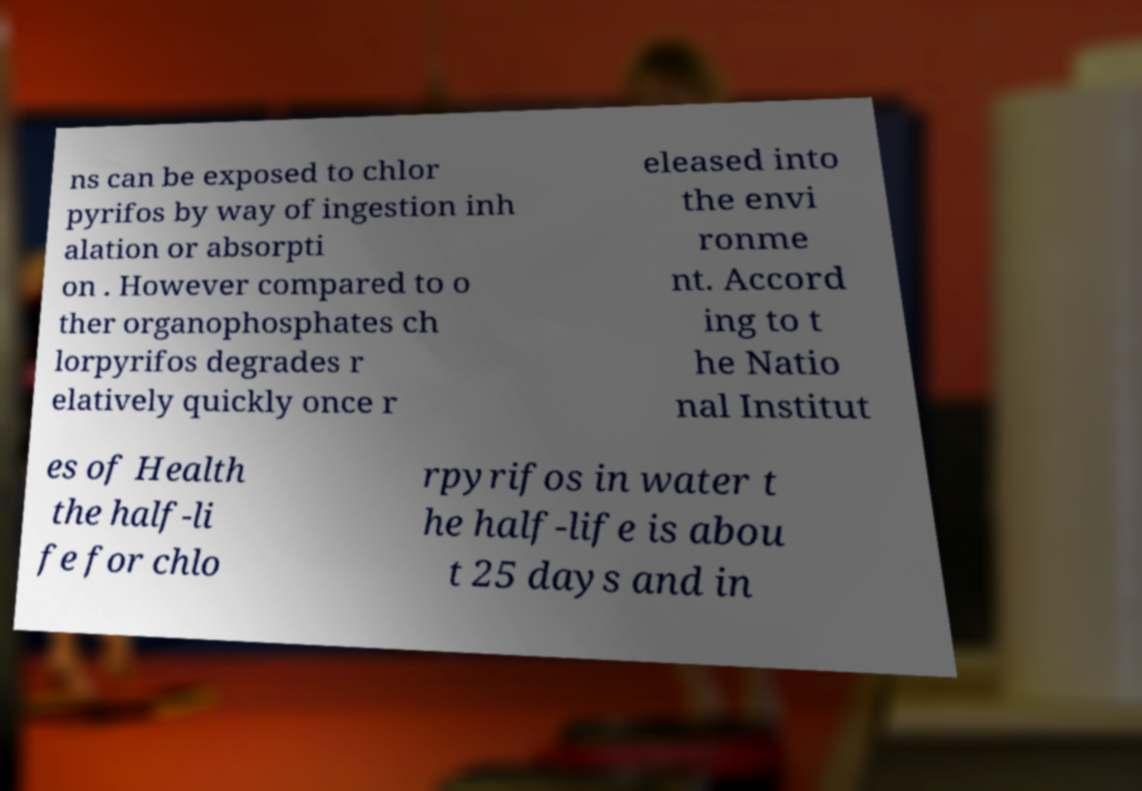What messages or text are displayed in this image? I need them in a readable, typed format. ns can be exposed to chlor pyrifos by way of ingestion inh alation or absorpti on . However compared to o ther organophosphates ch lorpyrifos degrades r elatively quickly once r eleased into the envi ronme nt. Accord ing to t he Natio nal Institut es of Health the half-li fe for chlo rpyrifos in water t he half-life is abou t 25 days and in 